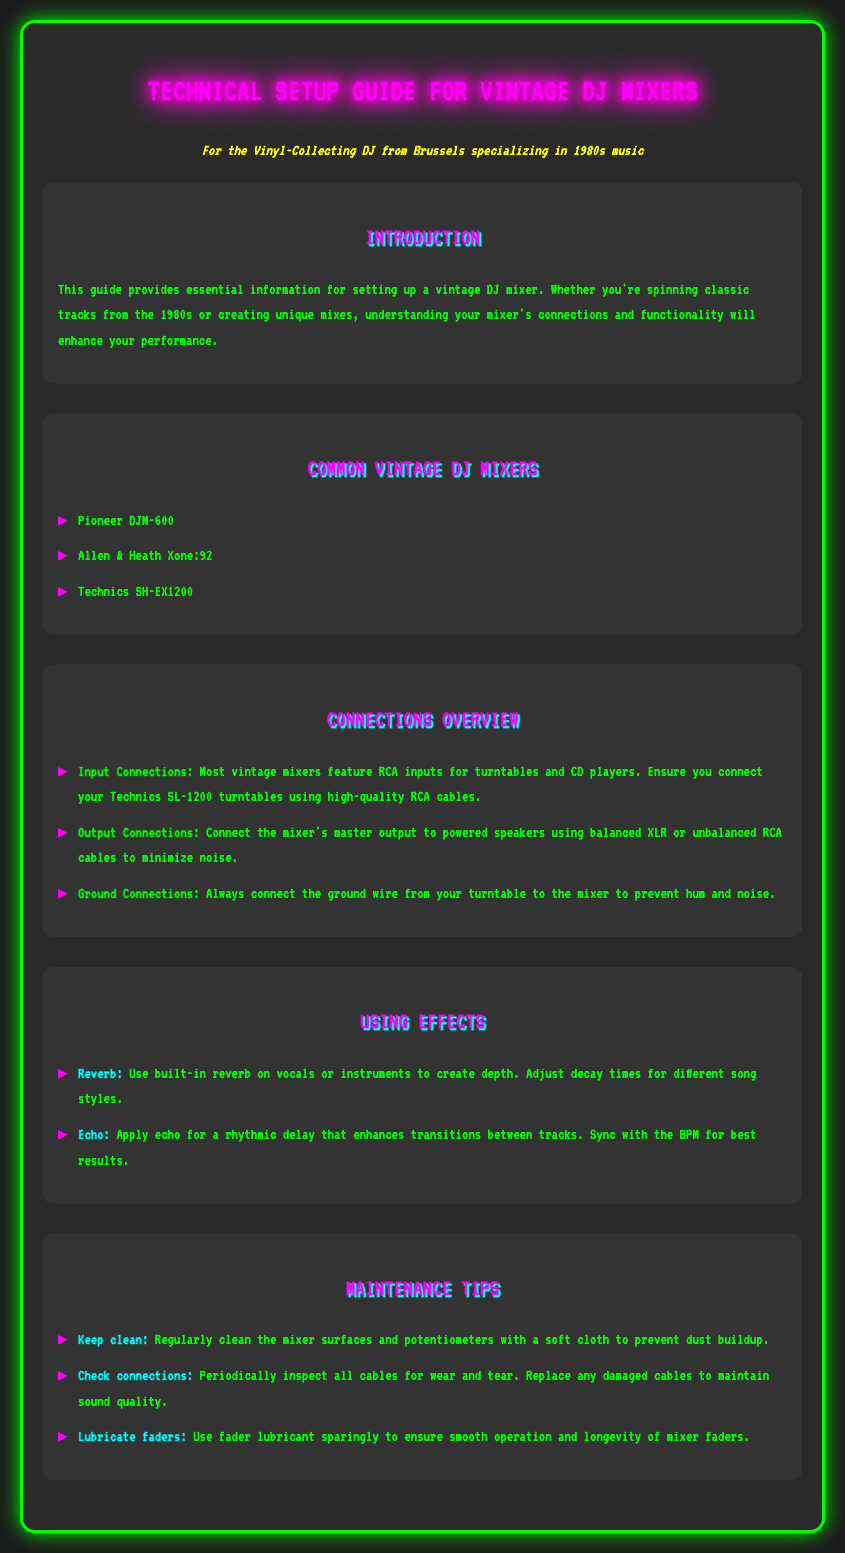what are the common vintage DJ mixers listed? The document lists Pioneer DJM-600, Allen & Heath Xone:92, and Technics SH-EX1200 as common vintage DJ mixers.
Answer: Pioneer DJM-600, Allen & Heath Xone:92, Technics SH-EX1200 what type of cables should be used for input connections? The document specifies that high-quality RCA cables should be used for turntable inputs.
Answer: RCA cables what is essential to connect to prevent noise? The guide mentions that connecting the ground wire from your turntable to the mixer is essential to prevent hum and noise.
Answer: Ground wire which effect creates depth in vocals or instruments? The document states that reverb is the effect used to create depth in vocals or instruments.
Answer: Reverb how should output connections minimize noise? The document explains that using balanced XLR or unbalanced RCA cables for output can minimize noise.
Answer: Balanced XLR or unbalanced RCA cables what is a tip for keeping the mixer clean? The document suggests regularly cleaning the mixer surfaces with a soft cloth to prevent dust buildup.
Answer: Clean with a soft cloth what should be periodically inspected for wear and tear? The document advises periodically inspecting all cables for wear and tear.
Answer: Cables how can fader operation be ensured? The document recommends using fader lubricant sparingly to ensure smooth operation.
Answer: Fader lubricant which section explains how to use built-in effects? The section titled "Using Effects" explains how to use built-in effects on the DJ mixer.
Answer: Using Effects 